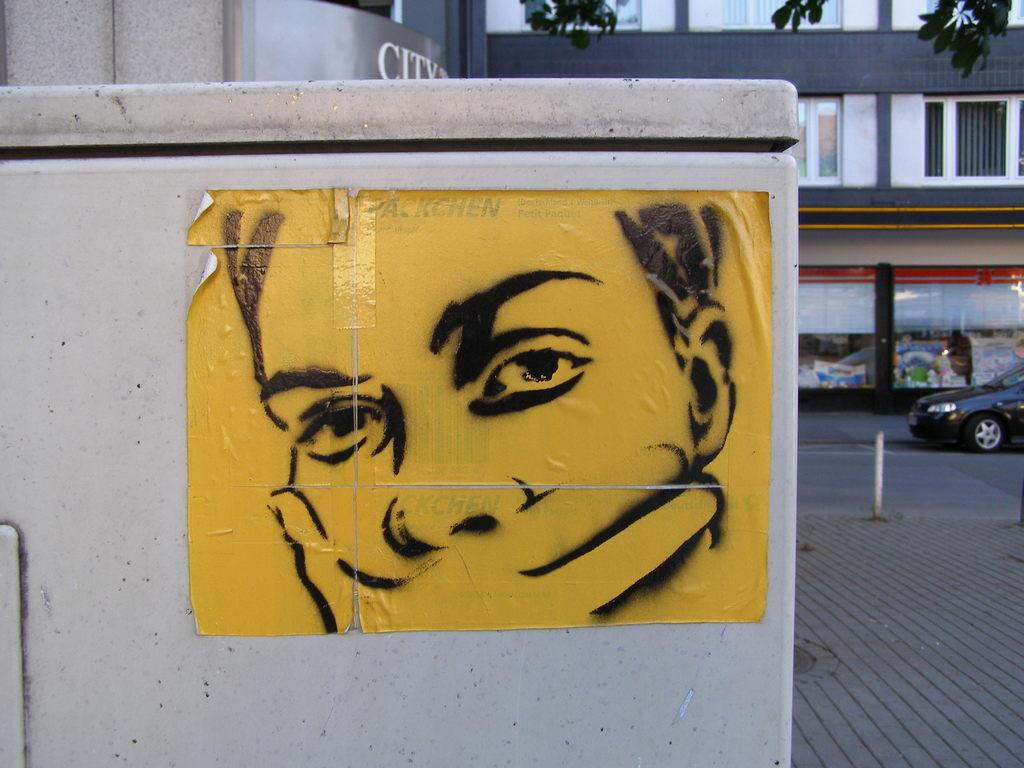What is featured in the image? There is a poster in the image. What can be seen in the background of the image? There is a building and a car in the background of the image. What type of kitten can be seen climbing a branch in the image? There is no kitten or branch present in the image; it only features a poster and background elements. 